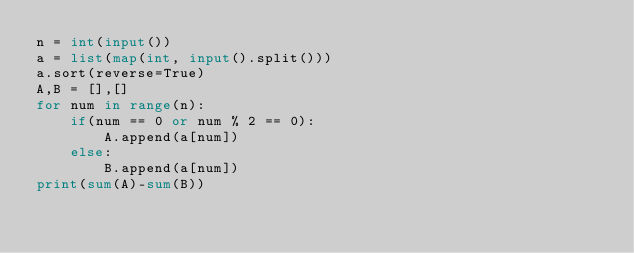Convert code to text. <code><loc_0><loc_0><loc_500><loc_500><_Python_>n = int(input())
a = list(map(int, input().split()))
a.sort(reverse=True)
A,B = [],[]
for num in range(n):
    if(num == 0 or num % 2 == 0):
        A.append(a[num])
    else:
        B.append(a[num])
print(sum(A)-sum(B))</code> 